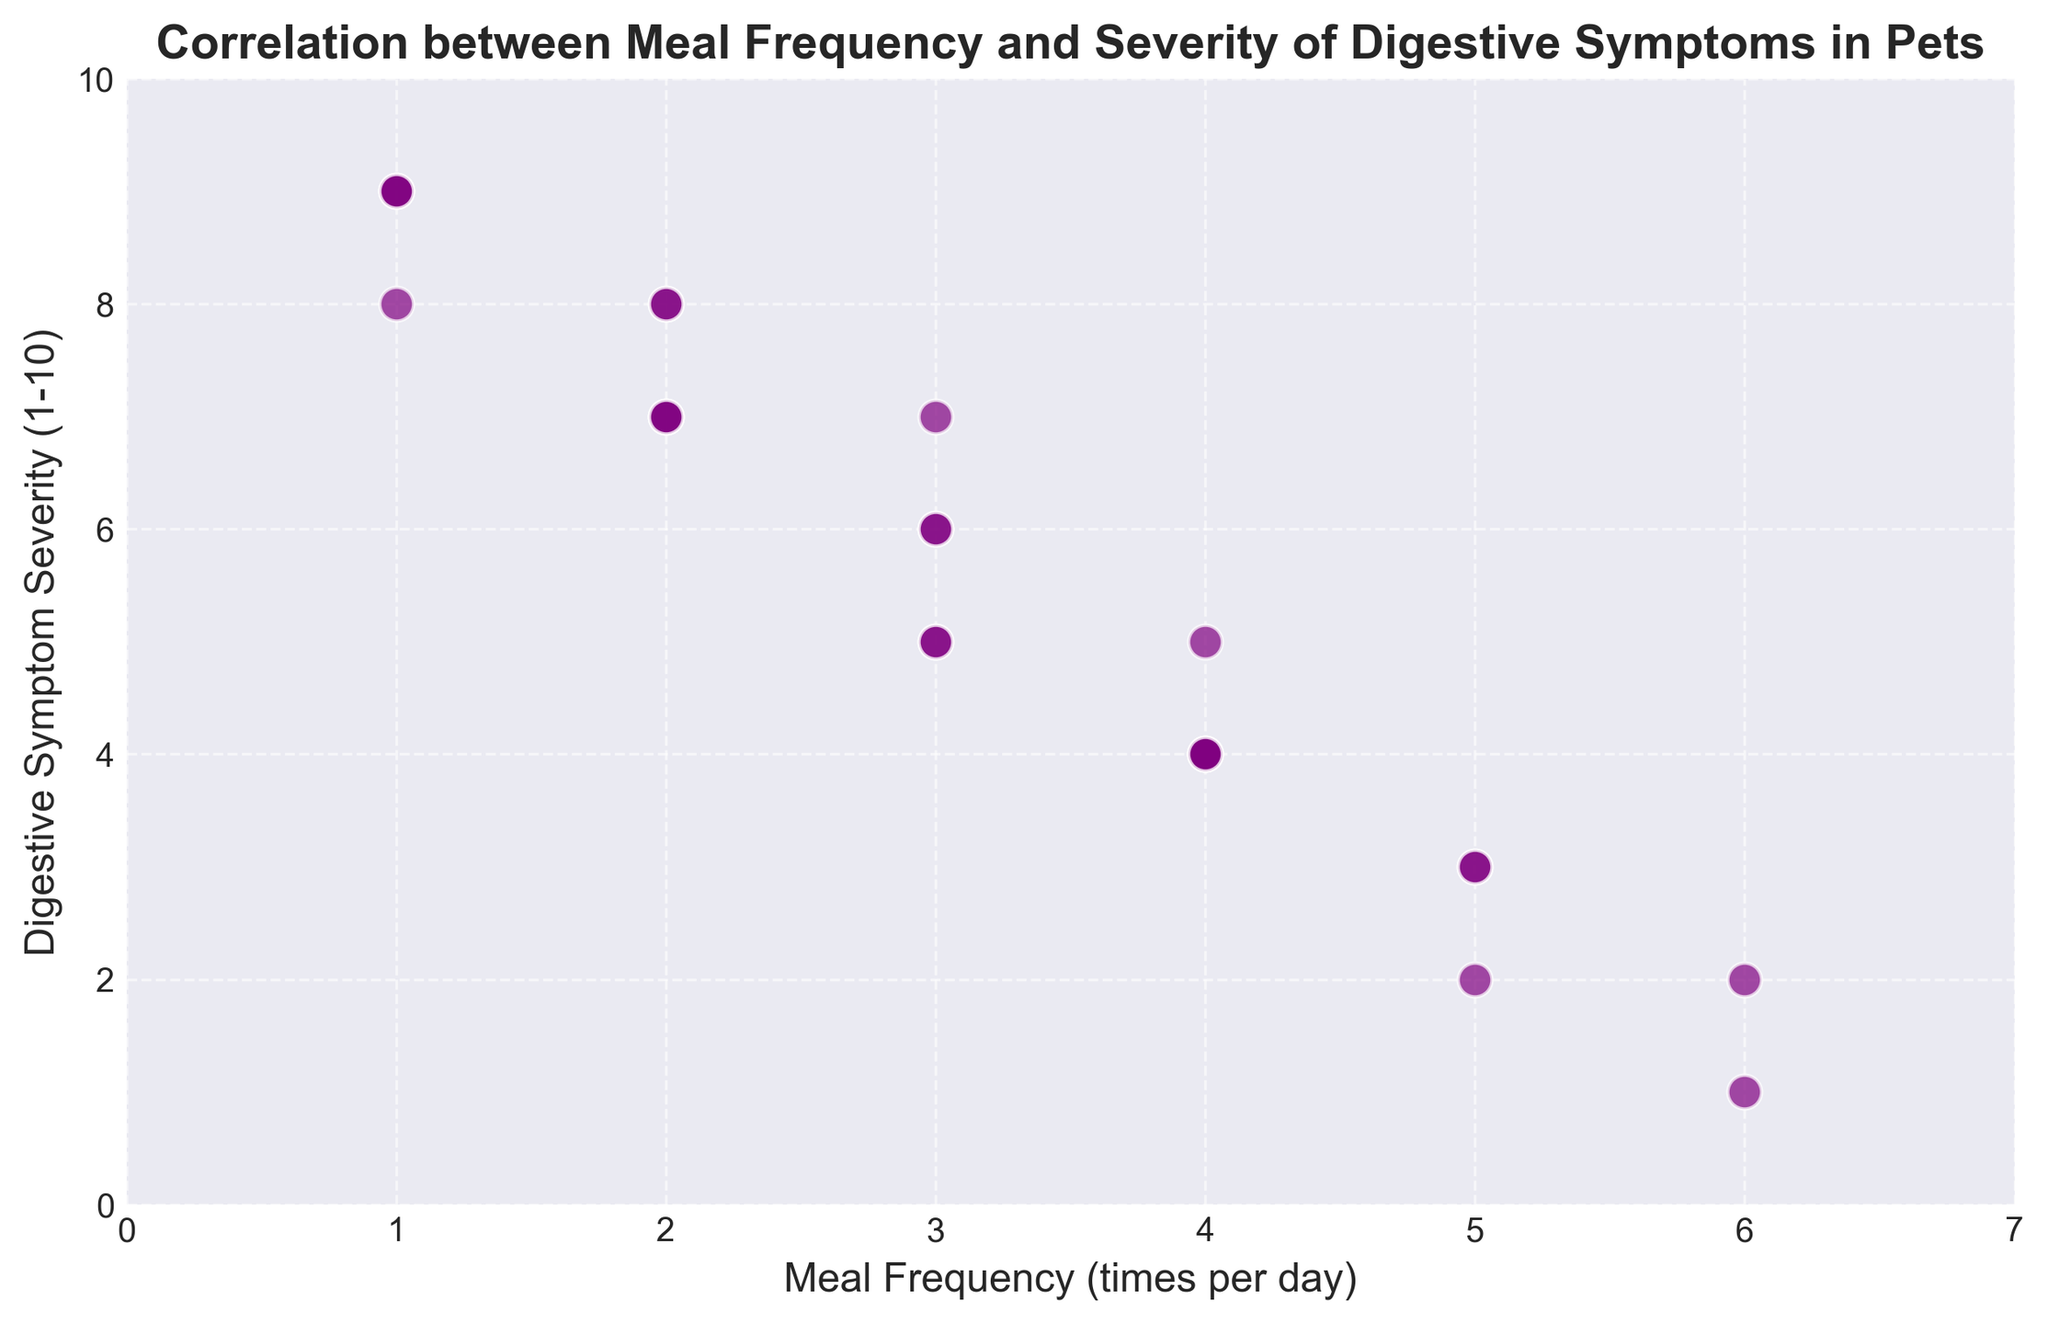What's the average severity of digestive symptoms for pets that have a meal frequency of 3 times per day? First, identify the data points where the meal frequency is 3 (there are 4 such points), and their symptom severities are 6, 6, 7, and 5. Sum these values: 6 + 6 + 7 + 5 = 24. Then, divide by the number of points: 24 / 4 = 6
Answer: 6 Which meal frequency corresponds to the lowest digestive symptom severity? Look for the minimum value in the Digestive Symptom Severity data column, which is 1. The corresponding meal frequency for this value is 6 times per day
Answer: 6 How many pets have a meal frequency of 2 times per day, and what is the range of their digestive symptom severity? First, count the number of data points where the meal frequency is 2 (there are 5 such points). Their symptom severities are 8, 7, 8, 7, and 7. The range is calculated by subtracting the minimum value from the maximum value. Here, the max is 8 and the min is 7, so the range is 8 - 7 = 1
Answer: 5, 1 Is there a visible trend between meal frequency and digestive symptom severity? Observe the scatter plot to see if there is a discernible pattern. It appears that higher meal frequencies tend to correspond to lower digestive symptom severity. This suggests a negative correlation between meal frequency and symptom severity
Answer: Negative correlation Which meal frequency has the most consistent digestive symptom severity? Identify the meal frequency with the lowest variability in its severity values. For example, meal frequency of 4 has severities of 5, 4, 4, 4, and 4, which is quite consistent compared to other meal frequencies
Answer: 4 What is the digestive symptom severity range for pets with a meal frequency of 1? Identify the data points for a meal frequency of 1 and their associated symptom severities (9, 8, 9, and 9). The range is the difference between the maximum and minimum values: 9 - 8 = 1
Answer: 1 Compare the average digestive symptom severity for pets with meal frequencies of 5 and 6 times per day. Calculate the average severity for both frequencies. For frequency 5, the severities are 3, 2, 3, and 3, so the average is (3 + 2 + 3 + 3) / 4 = 2.75. For frequency 6, the severities are 2 and 1, so the average is (2 + 1) / 2 = 1.5. Compare 2.75 and 1.5; 1.5 is lower
Answer: 1.5 (lower than 2.75) How many pets have digestive symptom severities of 4, and what are their meal frequencies? Identify all data points where the digestive symptom severity equals 4 (there are 4 such points). Their corresponding meal frequencies are 4, 4, 4, and 4
Answer: 4, 4 times per day 